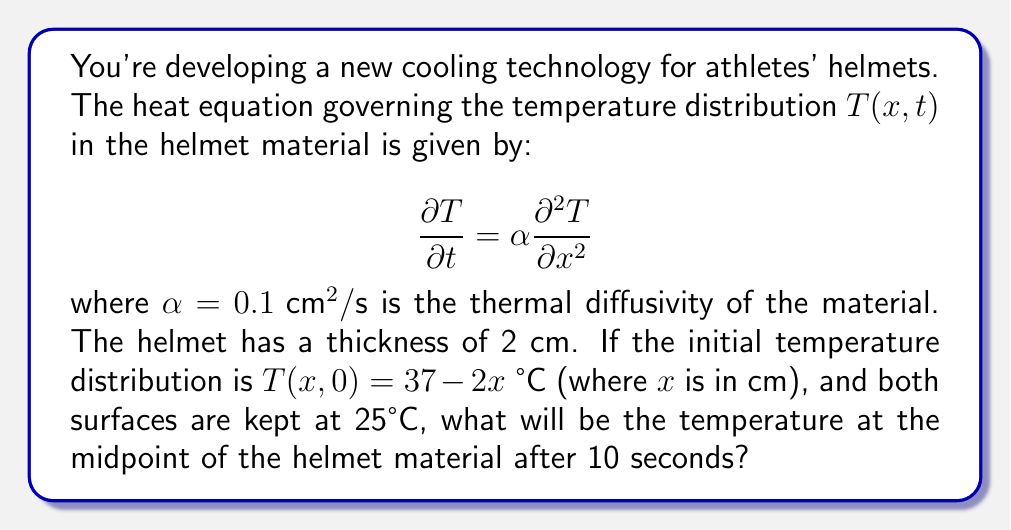What is the answer to this math problem? To solve this problem, we need to use the solution to the heat equation with given boundary conditions. The solution is given by the Fourier series:

$$T(x,t) = 25 + \sum_{n=1}^{\infty} B_n \sin(\frac{n\pi x}{L}) e^{-\alpha (\frac{n\pi}{L})^2 t}$$

where $L = 2$ cm is the thickness of the helmet.

Step 1: Calculate $B_n$
$$B_n = \frac{2}{L} \int_0^L (T(x,0) - 25) \sin(\frac{n\pi x}{L}) dx$$
$$= \frac{2}{2} \int_0^2 (12 - 2x) \sin(\frac{n\pi x}{2}) dx$$

Step 2: Solve the integral
$$B_n = \frac{24}{n\pi} - \frac{8}{n^2\pi^2} (\cos(n\pi) - 1)$$

Step 3: Simplify based on odd and even $n$
For odd $n$: $B_n = \frac{24}{n\pi} - \frac{16}{n^2\pi^2}$
For even $n$: $B_n = \frac{24}{n\pi}$

Step 4: Calculate temperature at midpoint $(x = 1)$ after 10 seconds
$$T(1,10) = 25 + \sum_{n=1}^{\infty} B_n \sin(\frac{n\pi}{2}) e^{-0.1 (\frac{n\pi}{2})^2 10}$$

Step 5: Approximate the sum using the first few terms (e.g., $n = 1, 3, 5$)
$$T(1,10) \approx 25 + 7.36 \cdot e^{-2.47} + 0.77 \cdot e^{-22.21} + 0.20 \cdot e^{-61.69}$$
$$\approx 25.72 \text{ °C}$$
Answer: 25.72 °C 